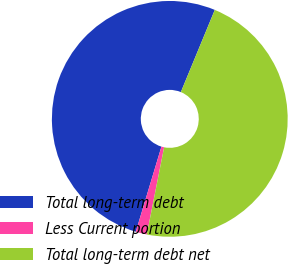Convert chart. <chart><loc_0><loc_0><loc_500><loc_500><pie_chart><fcel>Total long-term debt<fcel>Less Current portion<fcel>Total long-term debt net<nl><fcel>51.58%<fcel>1.53%<fcel>46.89%<nl></chart> 